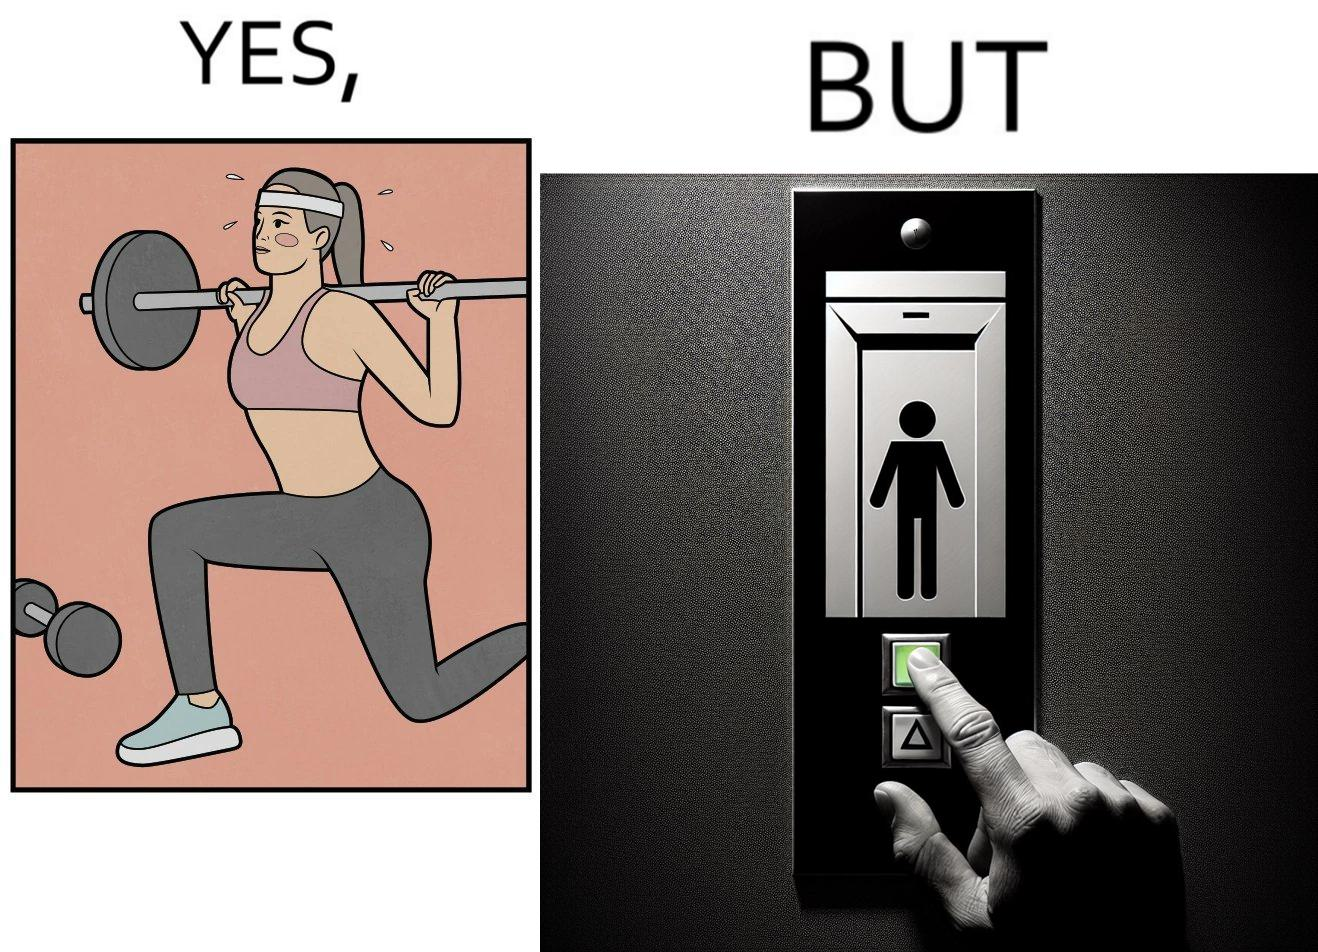What does this image depict? The image is satirical because it shows that while people do various kinds of exercises and go to gym to stay fit, they avoid doing simplest of physical tasks like using stairs instead of elevators to get to even the first or the second floor of a building. 